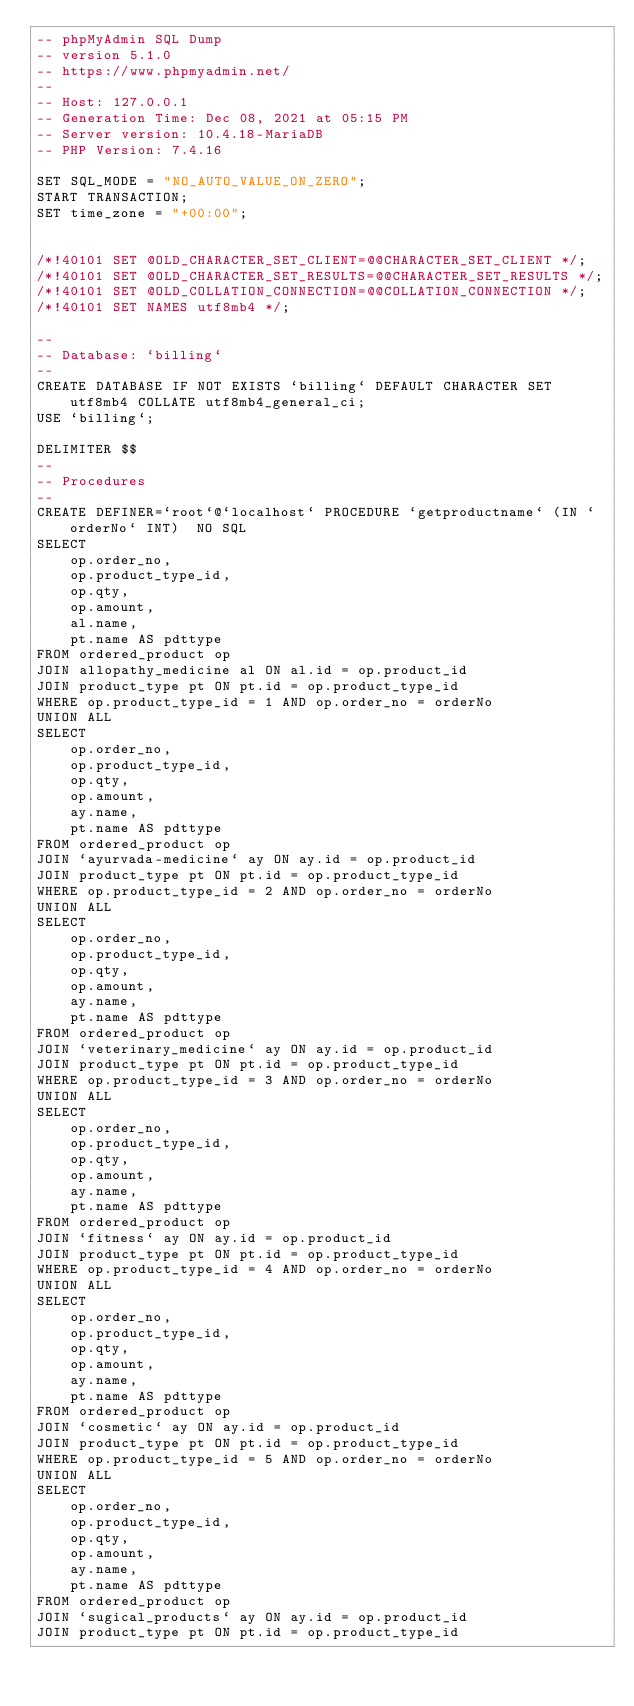<code> <loc_0><loc_0><loc_500><loc_500><_SQL_>-- phpMyAdmin SQL Dump
-- version 5.1.0
-- https://www.phpmyadmin.net/
--
-- Host: 127.0.0.1
-- Generation Time: Dec 08, 2021 at 05:15 PM
-- Server version: 10.4.18-MariaDB
-- PHP Version: 7.4.16

SET SQL_MODE = "NO_AUTO_VALUE_ON_ZERO";
START TRANSACTION;
SET time_zone = "+00:00";


/*!40101 SET @OLD_CHARACTER_SET_CLIENT=@@CHARACTER_SET_CLIENT */;
/*!40101 SET @OLD_CHARACTER_SET_RESULTS=@@CHARACTER_SET_RESULTS */;
/*!40101 SET @OLD_COLLATION_CONNECTION=@@COLLATION_CONNECTION */;
/*!40101 SET NAMES utf8mb4 */;

--
-- Database: `billing`
--
CREATE DATABASE IF NOT EXISTS `billing` DEFAULT CHARACTER SET utf8mb4 COLLATE utf8mb4_general_ci;
USE `billing`;

DELIMITER $$
--
-- Procedures
--
CREATE DEFINER=`root`@`localhost` PROCEDURE `getproductname` (IN `orderNo` INT)  NO SQL
SELECT
    op.order_no,
    op.product_type_id,
    op.qty,
    op.amount,
    al.name,
    pt.name AS pdttype
FROM ordered_product op
JOIN allopathy_medicine al ON al.id = op.product_id
JOIN product_type pt ON pt.id = op.product_type_id
WHERE op.product_type_id = 1 AND op.order_no = orderNo
UNION ALL
SELECT
    op.order_no,
    op.product_type_id,
    op.qty,
    op.amount,
    ay.name,
    pt.name AS pdttype
FROM ordered_product op
JOIN `ayurvada-medicine` ay ON ay.id = op.product_id
JOIN product_type pt ON pt.id = op.product_type_id
WHERE op.product_type_id = 2 AND op.order_no = orderNo
UNION ALL
SELECT
    op.order_no,
    op.product_type_id,
    op.qty,
    op.amount,
    ay.name,
    pt.name AS pdttype
FROM ordered_product op
JOIN `veterinary_medicine` ay ON ay.id = op.product_id
JOIN product_type pt ON pt.id = op.product_type_id
WHERE op.product_type_id = 3 AND op.order_no = orderNo
UNION ALL
SELECT
    op.order_no,
    op.product_type_id,
    op.qty,
    op.amount,
    ay.name,
    pt.name AS pdttype
FROM ordered_product op
JOIN `fitness` ay ON ay.id = op.product_id
JOIN product_type pt ON pt.id = op.product_type_id
WHERE op.product_type_id = 4 AND op.order_no = orderNo
UNION ALL
SELECT
    op.order_no,
    op.product_type_id,
    op.qty,
    op.amount,
    ay.name,
    pt.name AS pdttype
FROM ordered_product op
JOIN `cosmetic` ay ON ay.id = op.product_id
JOIN product_type pt ON pt.id = op.product_type_id
WHERE op.product_type_id = 5 AND op.order_no = orderNo
UNION ALL
SELECT
    op.order_no,
    op.product_type_id,
    op.qty,
    op.amount,
    ay.name,
    pt.name AS pdttype
FROM ordered_product op
JOIN `sugical_products` ay ON ay.id = op.product_id
JOIN product_type pt ON pt.id = op.product_type_id</code> 